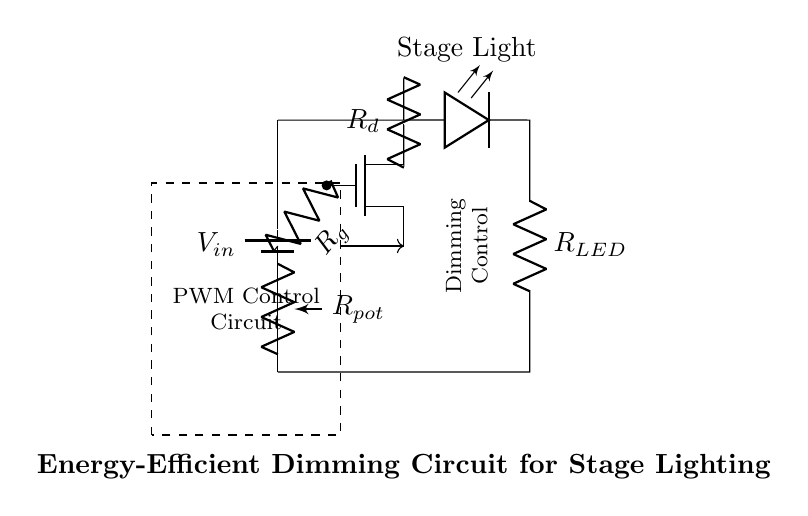What is the type of control used in this circuit? The circuit uses PWM (Pulse Width Modulation) control, as indicated by the dashed rectangle labeled “PWM Control Circuit” that manages the dimming function.
Answer: PWM What component is used for dimming the stage light? The dimming of the stage light is controlled by the MOSFET, which allows varying levels of power to the LED based on the PWM signal it receives.
Answer: MOSFET What is the role of the potentiometer in this circuit? The potentiometer is denoted as R_pot; it allows for variable resistance, which adjusts the control voltage to the MOSFET, thus influencing the brightness of the LED stage light.
Answer: Variable resistance What happens to the output voltage across the LED when the resistance in the potentiometer is increased? Increasing the resistance in the potentiometer decreases the control voltage to the MOSFET, leading to reduced LED brightness, as less current flows through the LED.
Answer: Reduced brightness How many resistors are present in this circuit diagram? There are three resistors in the circuit: R_g, R_d, and R_LED, each serving distinct functions like gate control, drain resistance, and in series with the LED.
Answer: Three What is the primary function of the components connected to the battery in this circuit? The primary function of the components connected to the battery is to create a controlled power source for the stage light, utilizing PWM to adjust brightness while maintaining energy efficiency.
Answer: Controlled power source 